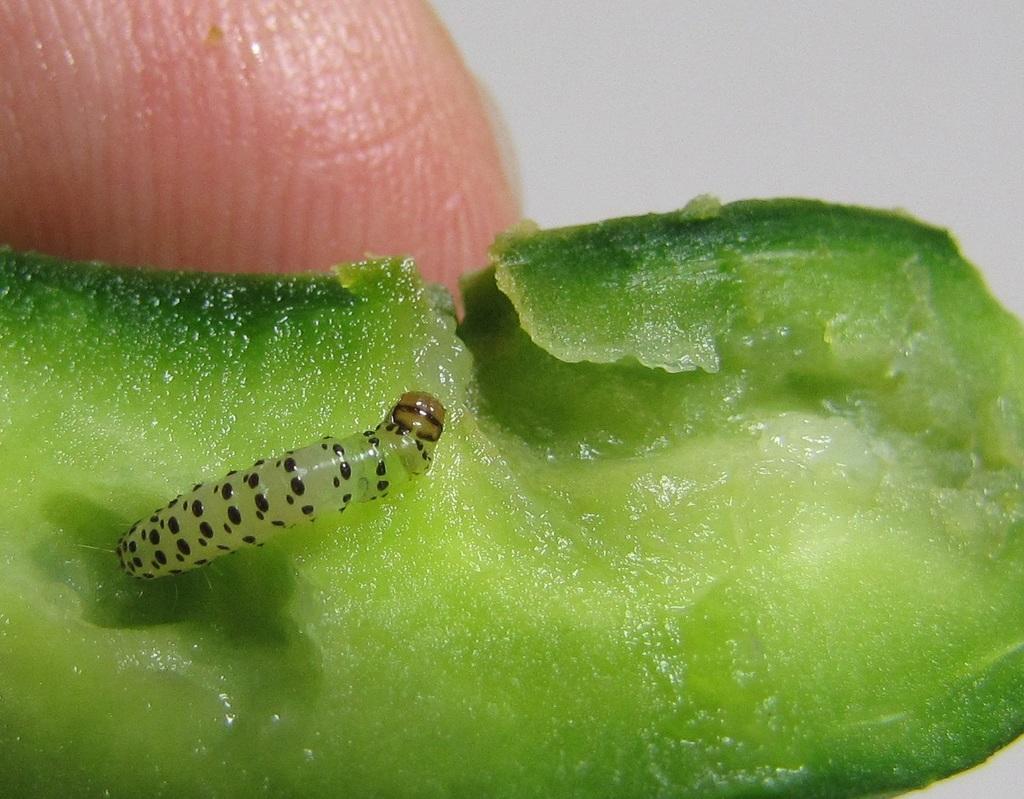Could you give a brief overview of what you see in this image? This image consists of an insect. It looks like it is in a vegetable. At the top, there is a finger of a person. 